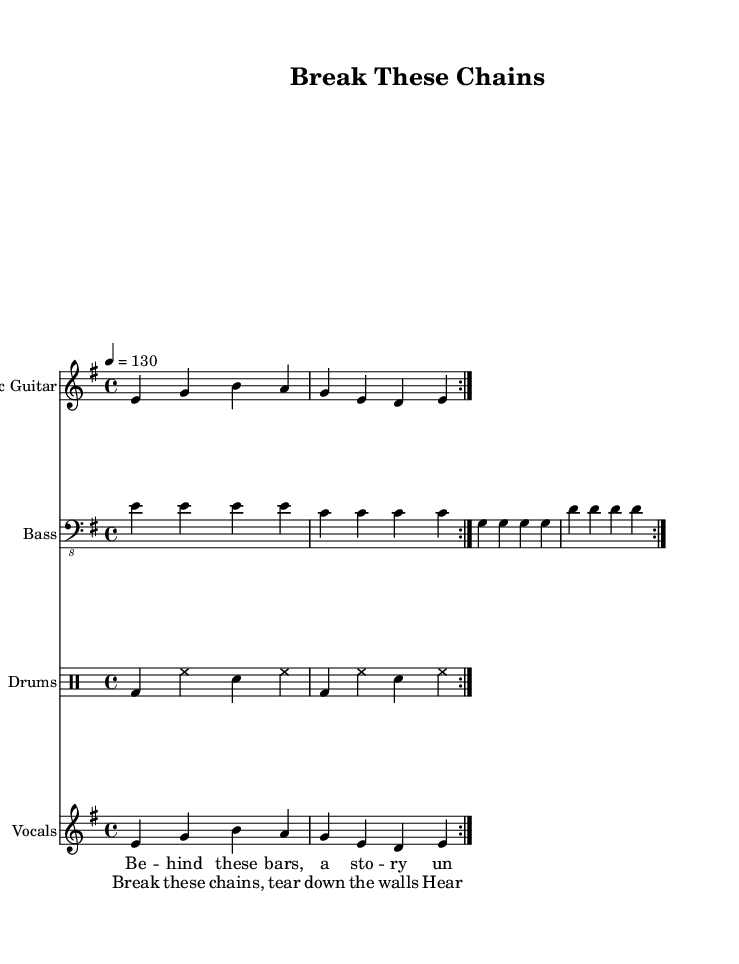What is the key signature of this music? The key signature is indicated at the beginning of the score, where it shows the key of E minor, which has one sharp (F#).
Answer: E minor What is the time signature of this music? The time signature is found at the beginning of the sheet music; it shows 4/4, meaning there are four beats per measure.
Answer: 4/4 What is the tempo marking for this piece? The tempo marking is given at the beginning of the piece, stating that the tempo is 130 beats per minute.
Answer: 130 How many times is the verse repeated? The score indicates that both the electric guitar and vocals sections contain a "repeat volta 2" marking, hence both are repeated twice.
Answer: 2 What is the primary theme of the lyrics? By evaluating the lyrics, they mention breaking chains and justice, indicating a focus on prison reform and social justice issues.
Answer: Justice What instrument plays the bass part? The sheet music explicitly labels the second staff as "Bass," indicating that this staff represents the bass guitar.
Answer: Bass guitar What type of song structure is evident in this piece? The piece has a clear distinction between verse and chorus segments, evident from the repeated lyric sections and musical phrases.
Answer: Verse-Chorus 